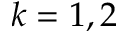Convert formula to latex. <formula><loc_0><loc_0><loc_500><loc_500>k = 1 , 2</formula> 